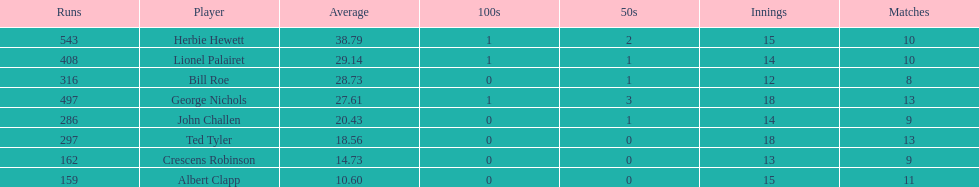How many runs did ted tyler have? 297. 